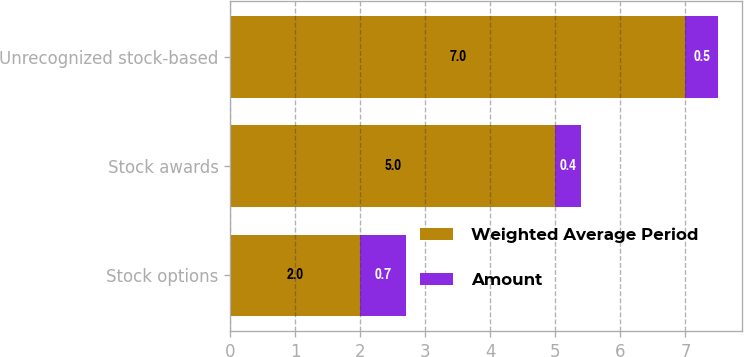Convert chart to OTSL. <chart><loc_0><loc_0><loc_500><loc_500><stacked_bar_chart><ecel><fcel>Stock options<fcel>Stock awards<fcel>Unrecognized stock-based<nl><fcel>Weighted Average Period<fcel>2<fcel>5<fcel>7<nl><fcel>Amount<fcel>0.7<fcel>0.4<fcel>0.5<nl></chart> 